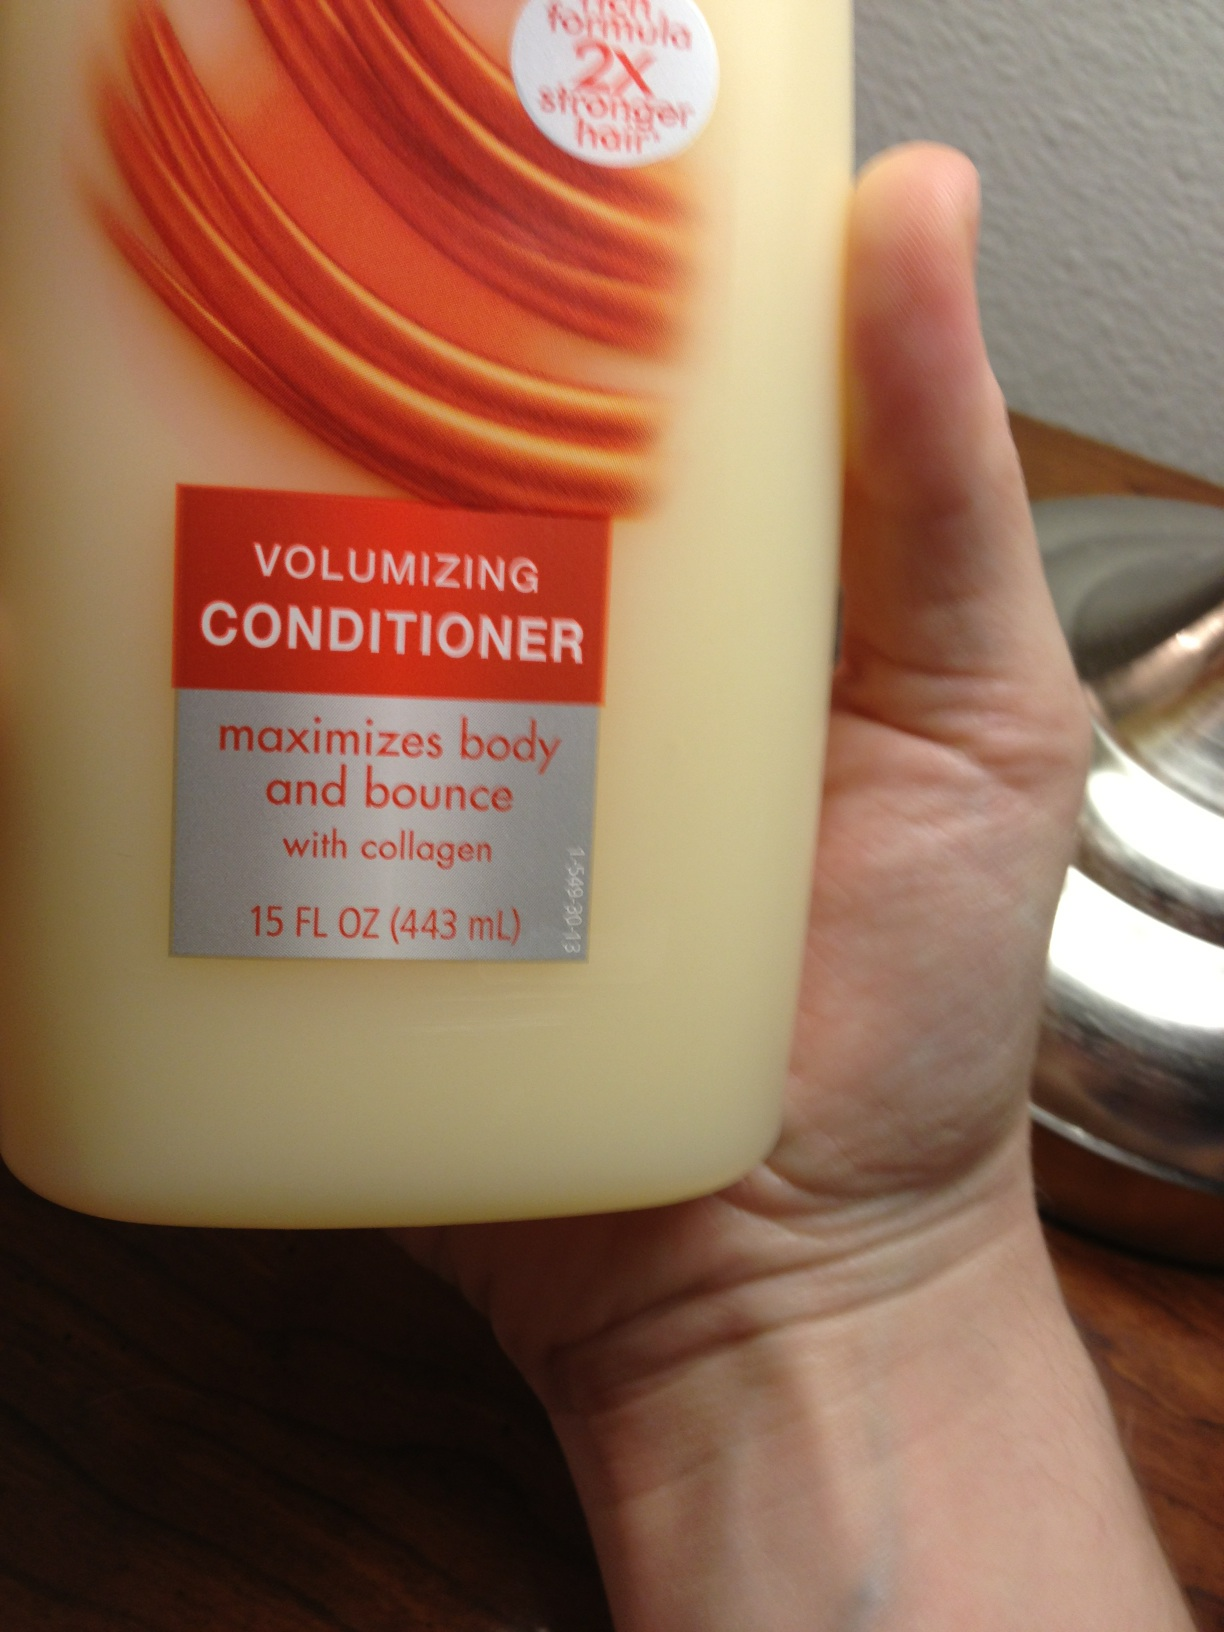Is this shampoo? from Vizwiz no 